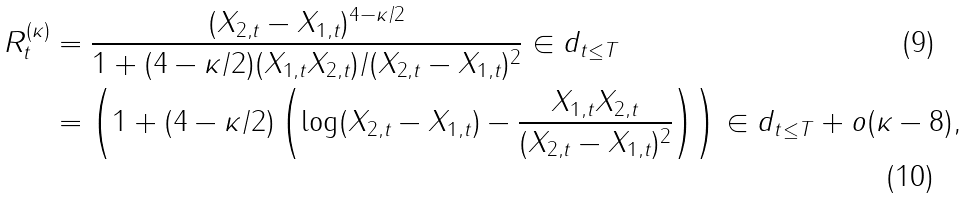Convert formula to latex. <formula><loc_0><loc_0><loc_500><loc_500>R ^ { ( \kappa ) } _ { t } & = \frac { ( X _ { 2 , t } - X _ { 1 , t } ) ^ { 4 - \kappa / 2 } } { 1 + ( 4 - \kappa / 2 ) ( X _ { 1 , t } X _ { 2 , t } ) / ( X _ { 2 , t } - X _ { 1 , t } ) ^ { 2 } } \in d _ { t \leq T } \\ & = \left ( 1 + ( 4 - \kappa / 2 ) \left ( \log ( X _ { 2 , t } - X _ { 1 , t } ) - \frac { X _ { 1 , t } X _ { 2 , t } } { ( X _ { 2 , t } - X _ { 1 , t } ) ^ { 2 } } \right ) \right ) \in d _ { t \leq T } + o ( \kappa - 8 ) ,</formula> 